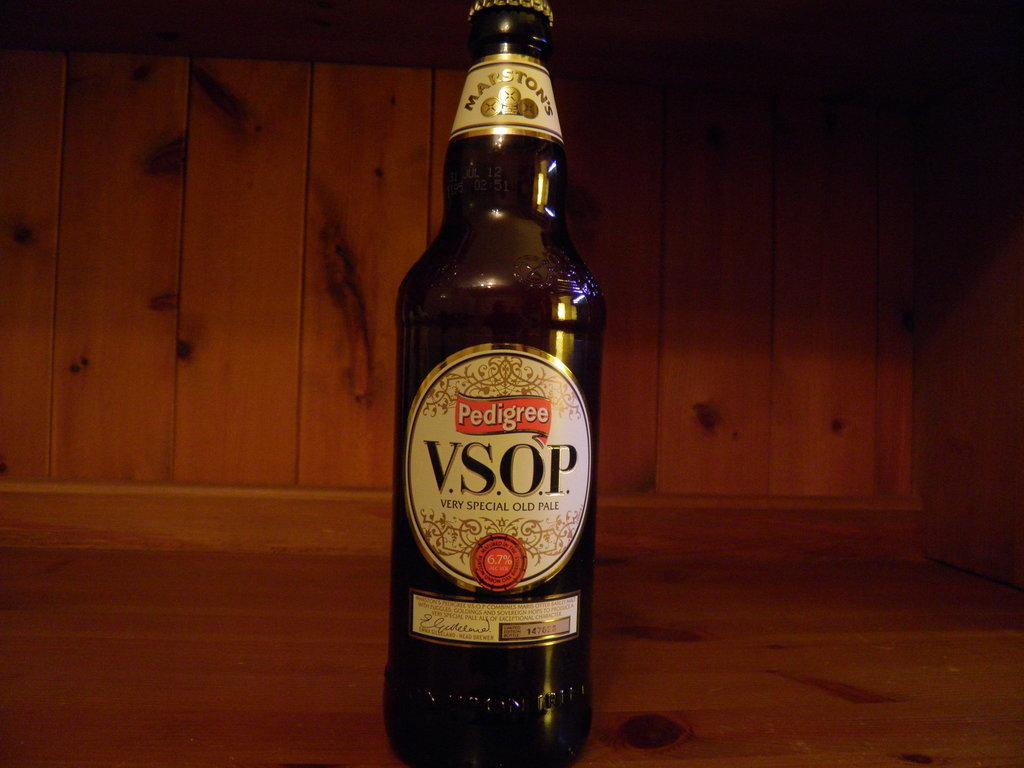<image>
Provide a brief description of the given image. A bottle of Pedigree V.S.O.P. beer on a wooden shelf. 